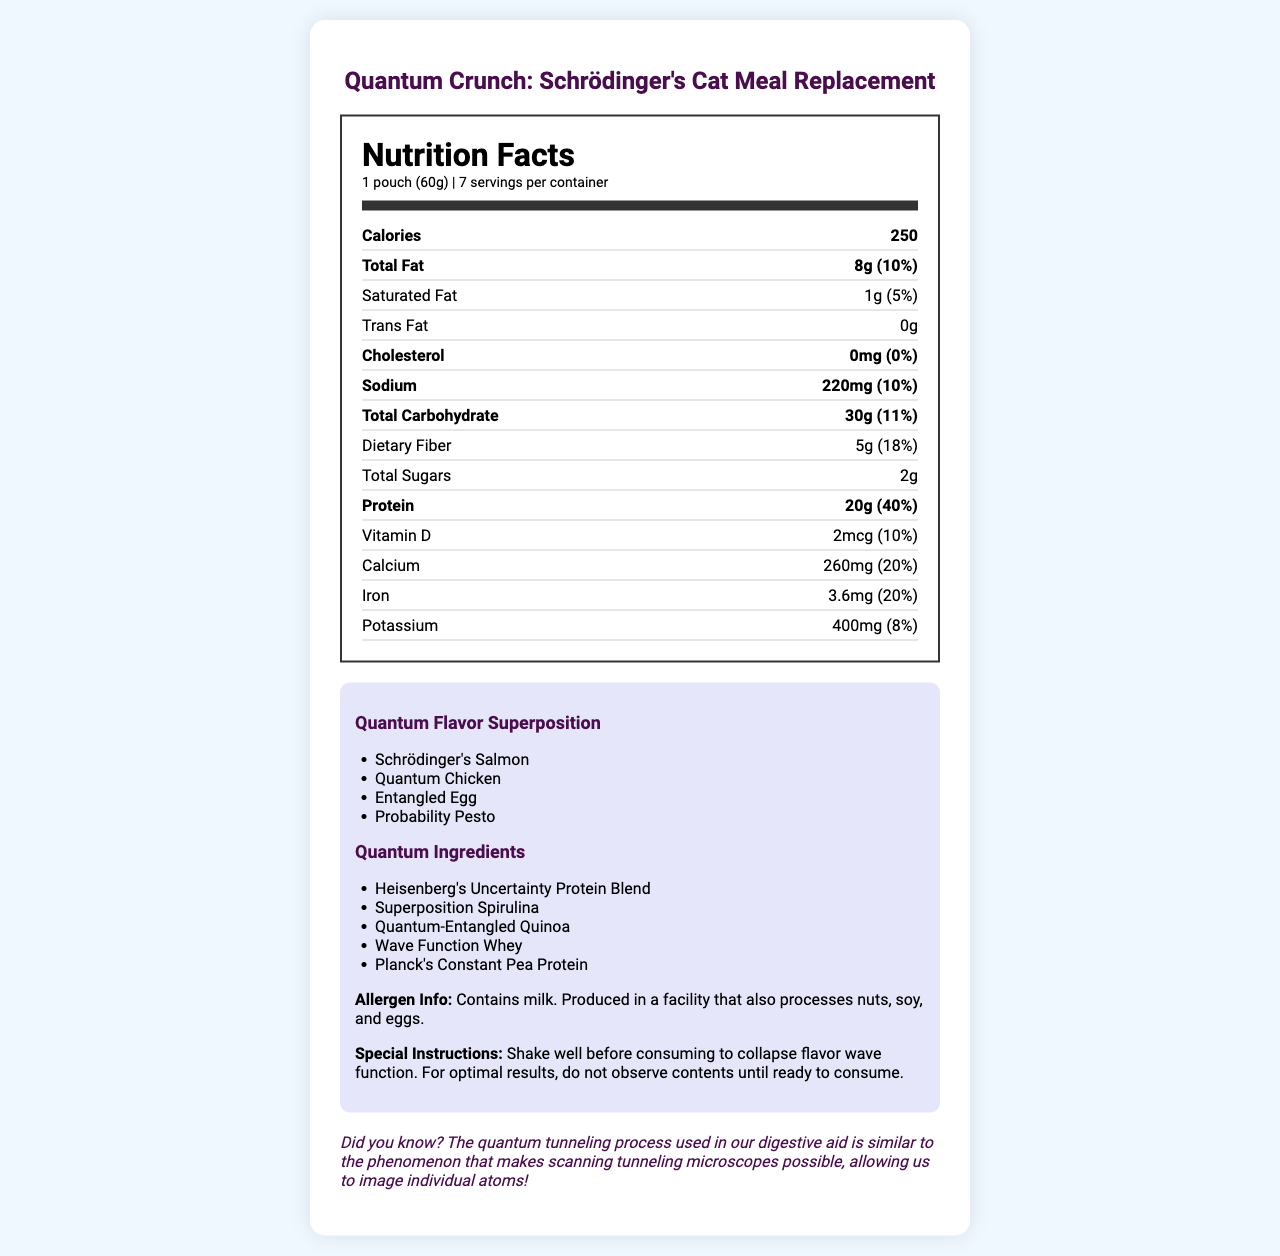what is the product name? The product name is stated at the top of the document in the header section.
Answer: Quantum Crunch: Schrödinger's Cat Meal Replacement what is the serving size? The serving size is shown in the header of the nutrition label as "1 pouch (60g)".
Answer: 1 pouch (60g) how many calories are in one serving? The calorie content is listed under the nutrition facts section, showing "250" calories.
Answer: 250 how much protein is in one serving? The amount of protein per serving is stated under the nutrition facts as "20g" with a daily value of "40%".
Answer: 20g what are the flavor options in the superposition? The flavor superposition options are listed under the "Quantum Flavor Superposition" section.
Answer: Schrödinger's Salmon, Quantum Chicken, Entangled Egg, Probability Pesto which of the following is NOT a quantum ingredient? A. Heisenberg's Uncertainty Protein Blend B. Quantum-Entangled Quinoa C. Schrödinger's Sugar D. Wave Function Whey Schrödinger's Sugar is not listed among the quantum ingredients, which include Heisenberg's Uncertainty Protein Blend, Superposition Spirulina, Quantum-Entangled Quinoa, Wave Function Whey, and Planck's Constant Pea Protein.
Answer: C. Schrödinger's Sugar what is the effectiveness percentage of the quantum tunneling digestive aid? Under the "quantum tunneling digestive aid" section, the effectiveness is stated to be "99.9% (as measured by Copenhagen interpretation)".
Answer: 99.9% how much sodium is in each serving? The sodium content per serving is listed as "220mg" with a daily value of "10%".
Answer: 220mg what are the active ingredients of the DigestQuantum Plus? A. Entangled Enzymes, Superposition Probiotics, Quantum Foam Fiber B. Superposition Spirulina, Wave Function Whey, Planck's Constant Pea Protein C. Schrödinger's Salmon, Quantum Chicken, Entangled Egg, Probability Pesto D. Total Fat, Saturated Fat, Trans Fat The active ingredients of DigestQuantum Plus are detailed as Entangled Enzymes, Superposition Probiotics, and Quantum Foam Fiber.
Answer: A. Entangled Enzymes, Superposition Probiotics, Quantum Foam Fiber is the product suitable for people with nut allergies? The allergen info states that it contains milk and is produced in a facility that also processes nuts, soy, and eggs.
Answer: No summarize the document in a few sentences. This document is designed to inform consumers about the unique aspects of the meal replacement product, combining elements of quantum physics with dietary information and advanced digestive aids.
Answer: The document provides detailed nutritional information and special features of the "Quantum Crunch: Schrödinger's Cat Meal Replacement." It includes a variety of quantum-themed flavors and ingredients, allergen information, and special instructions for consumption. Additionally, it features a quantum tunneling digestive aid called DigestQuantum Plus, graphic design elements based on quantum physics, and an interesting physics fun fact. How was the flavor wave function determined? The document mentions that one should "shake well before consuming to collapse the flavor wave function," but it does not provide any information on how the flavor wave function was determined.
Answer: Not enough information 